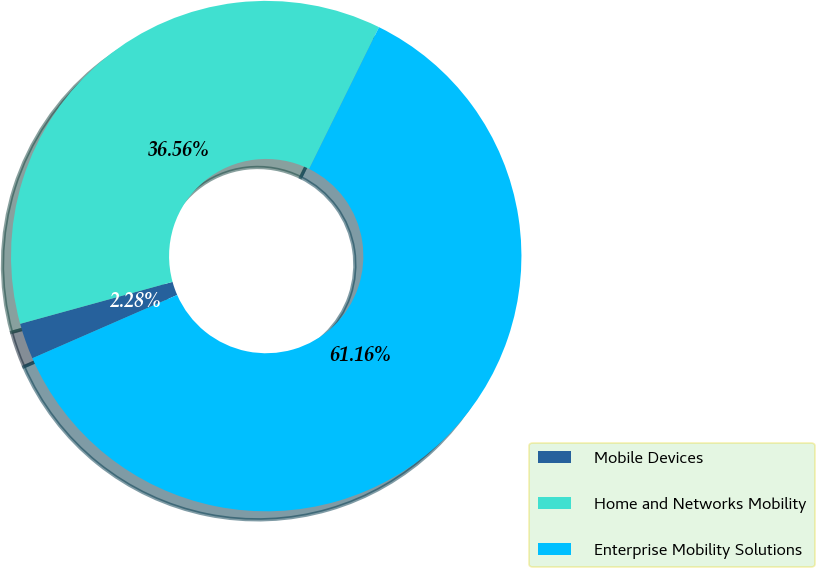Convert chart. <chart><loc_0><loc_0><loc_500><loc_500><pie_chart><fcel>Mobile Devices<fcel>Home and Networks Mobility<fcel>Enterprise Mobility Solutions<nl><fcel>2.28%<fcel>36.56%<fcel>61.16%<nl></chart> 